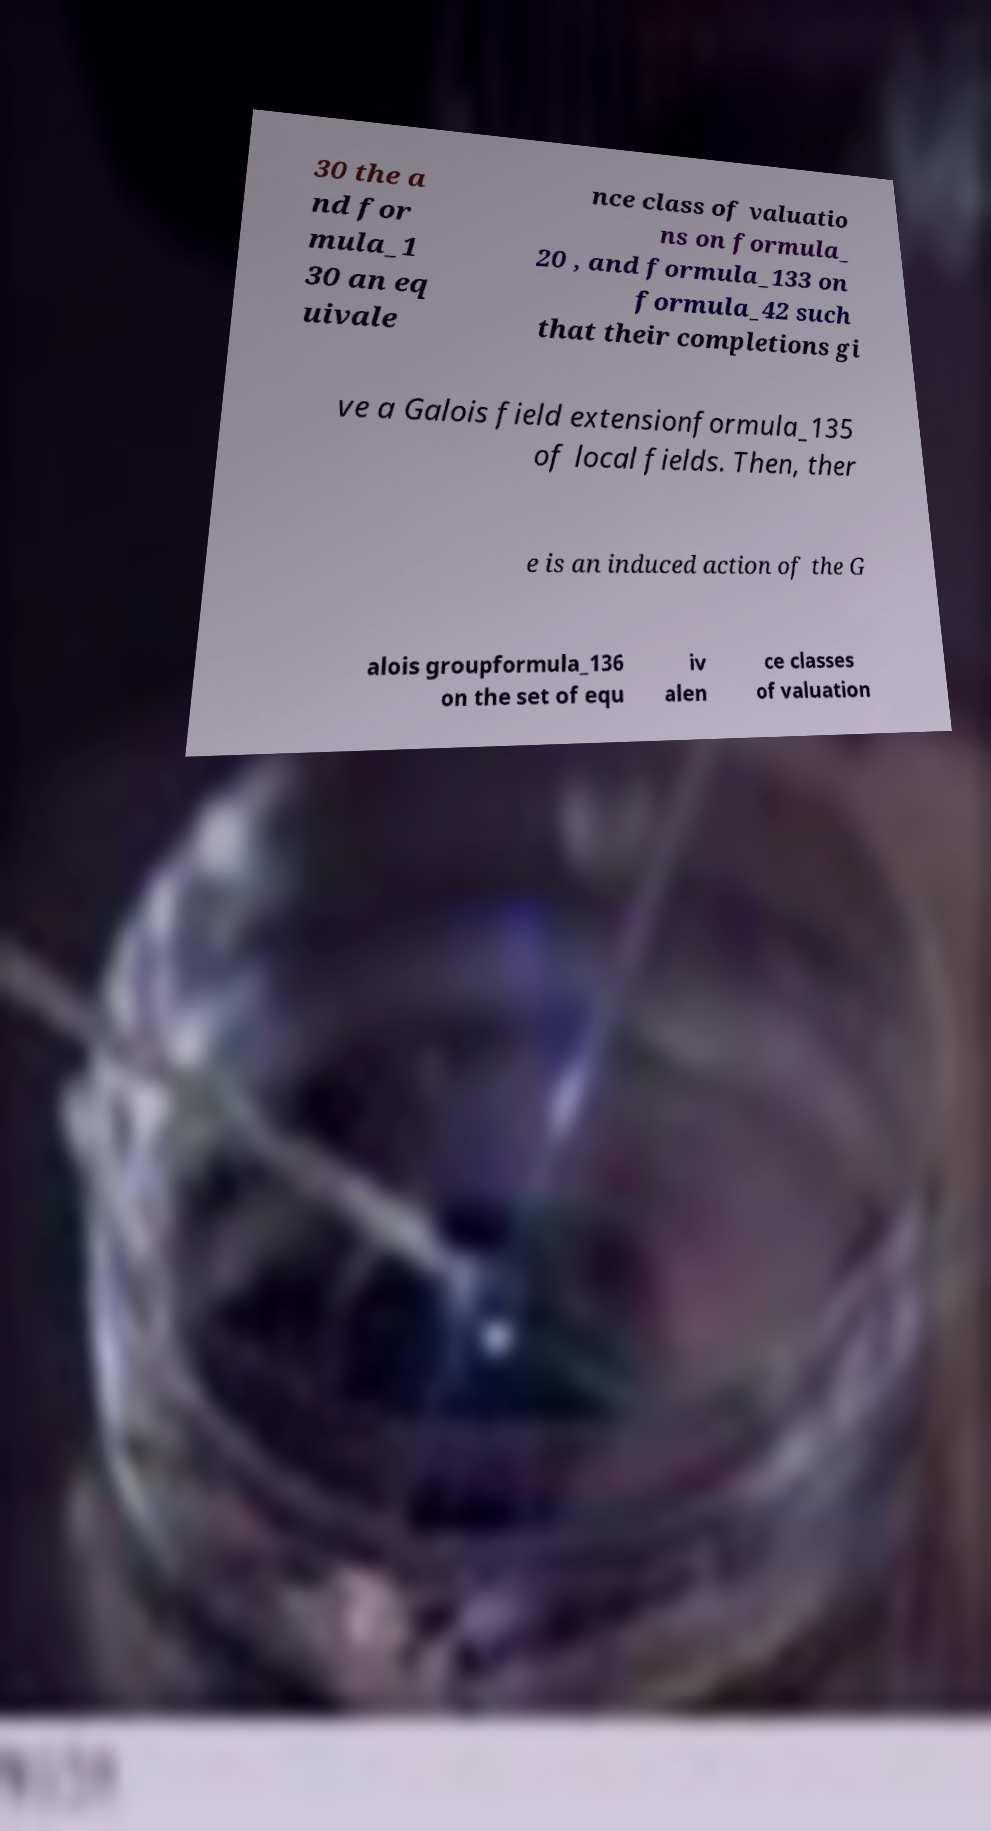Could you extract and type out the text from this image? 30 the a nd for mula_1 30 an eq uivale nce class of valuatio ns on formula_ 20 , and formula_133 on formula_42 such that their completions gi ve a Galois field extensionformula_135 of local fields. Then, ther e is an induced action of the G alois groupformula_136 on the set of equ iv alen ce classes of valuation 